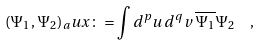<formula> <loc_0><loc_0><loc_500><loc_500>( \Psi _ { 1 } , \Psi _ { 2 } ) _ { a } u x \colon = \int d ^ { p } u \, d ^ { q } v \, \overline { \Psi _ { 1 } } \Psi _ { 2 } \ \ ,</formula> 